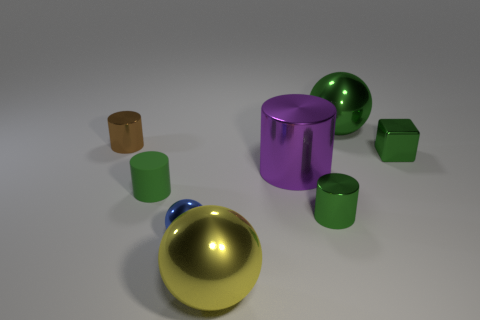Subtract all big shiny spheres. How many spheres are left? 1 Add 1 tiny shiny blocks. How many objects exist? 9 Subtract all brown cylinders. How many cylinders are left? 3 Subtract 3 spheres. How many spheres are left? 0 Subtract all red cubes. Subtract all red cylinders. How many cubes are left? 1 Subtract all red balls. How many brown cylinders are left? 1 Subtract 0 gray spheres. How many objects are left? 8 Subtract all blocks. How many objects are left? 7 Subtract all small gray cylinders. Subtract all big metal balls. How many objects are left? 6 Add 6 large yellow things. How many large yellow things are left? 7 